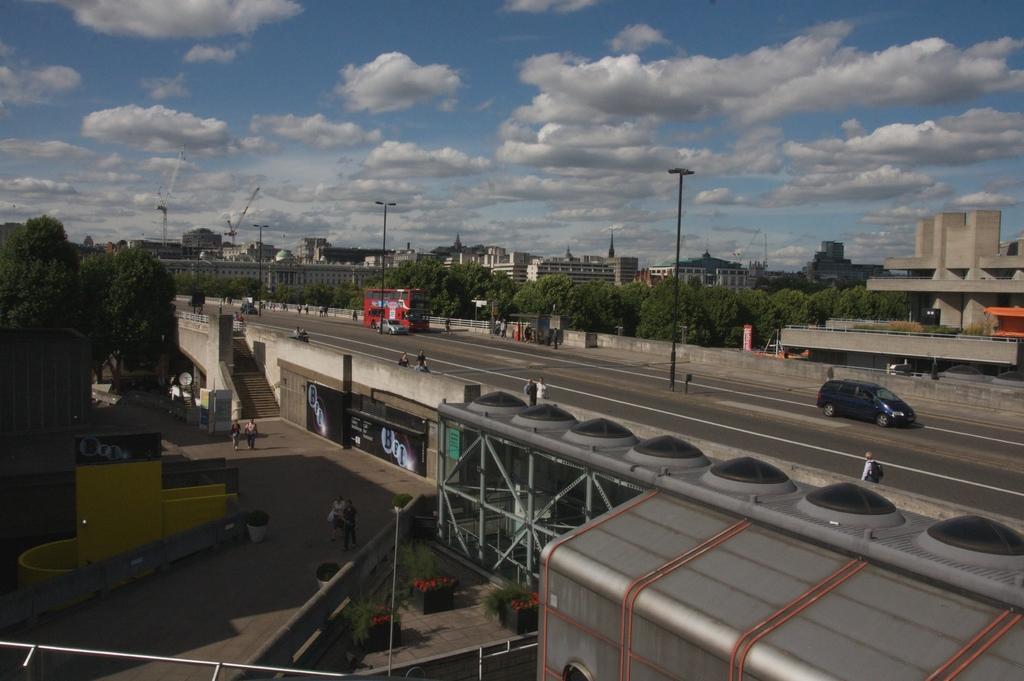Could you give a brief overview of what you see in this image? It is the outside view. In this image, we can see so many trees, buildings, bridge, vehicles, stairs, rods, poles. Here we can see few people. Top of the image, there is a cloudy sky. 